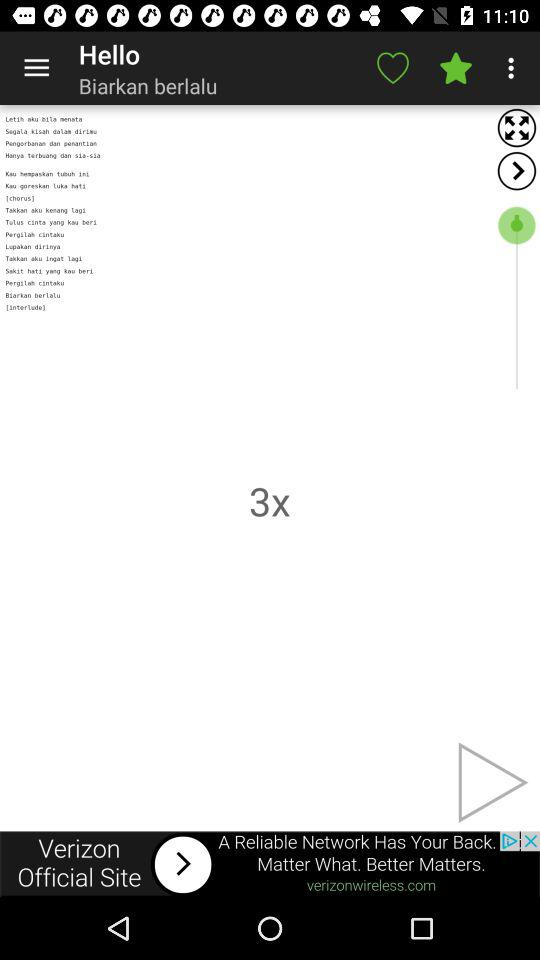What is the login name? The login name is "Biarkan berlalu". 